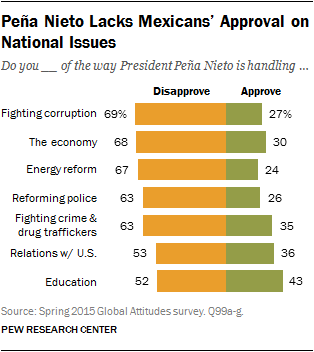Give some essential details in this illustration. There are multiple issues that have more than 65 respondents choosing to disapprove, specifically 3 of them. Seven issues are included in the graph. 